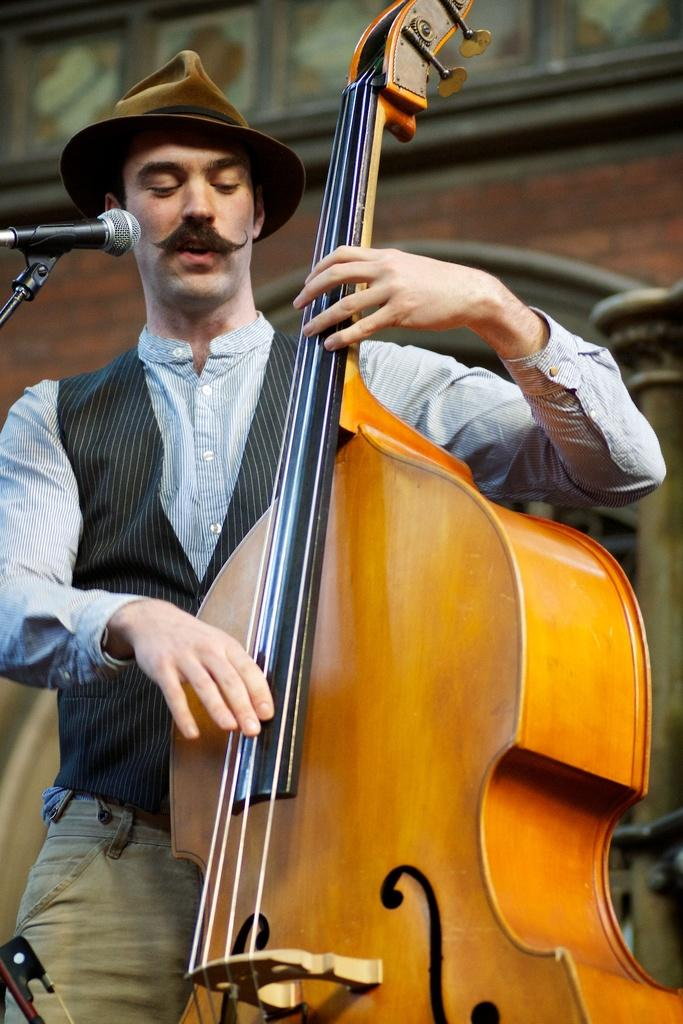What is the man in the image doing? The man is playing a guitar and singing a song. How is the man amplifying his voice in the image? The man is using a microphone. What can be seen in the background of the image? There is a wall in the background of the image. What type of kitty is taking a bath in the image? There is no kitty present in the image, and therefore no such activity can be observed. 